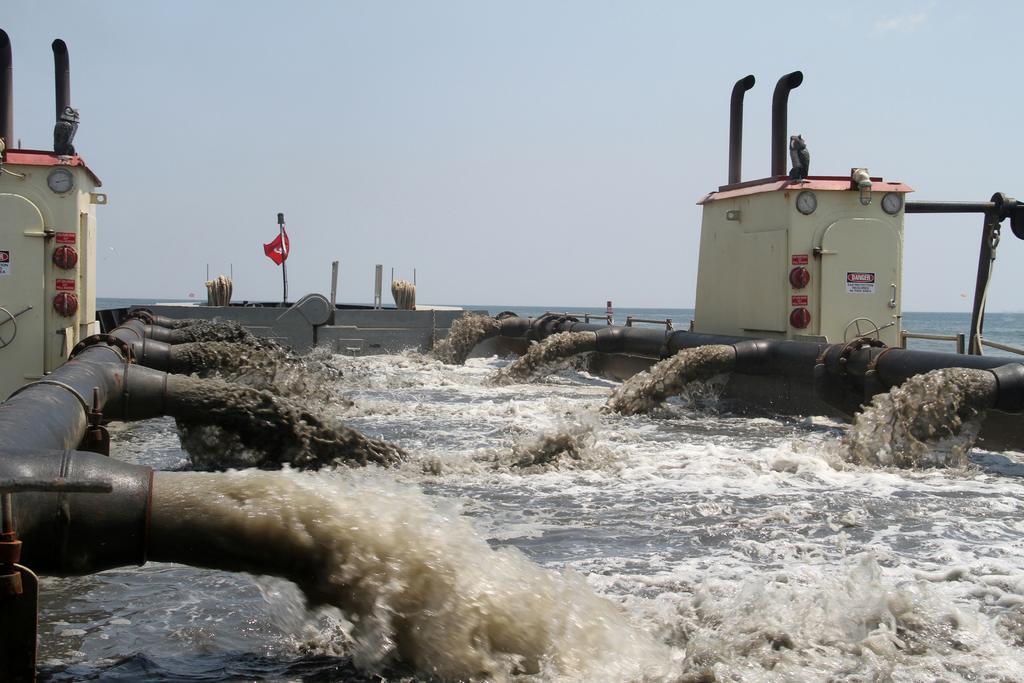Could you give a brief overview of what you see in this image? In this image we can see water, water pipe lines, electric house, flag and sky in the background. 